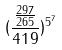<formula> <loc_0><loc_0><loc_500><loc_500>( \frac { \frac { 2 9 7 } { 2 6 5 } } { 4 1 9 } ) ^ { 5 ^ { 7 } }</formula> 